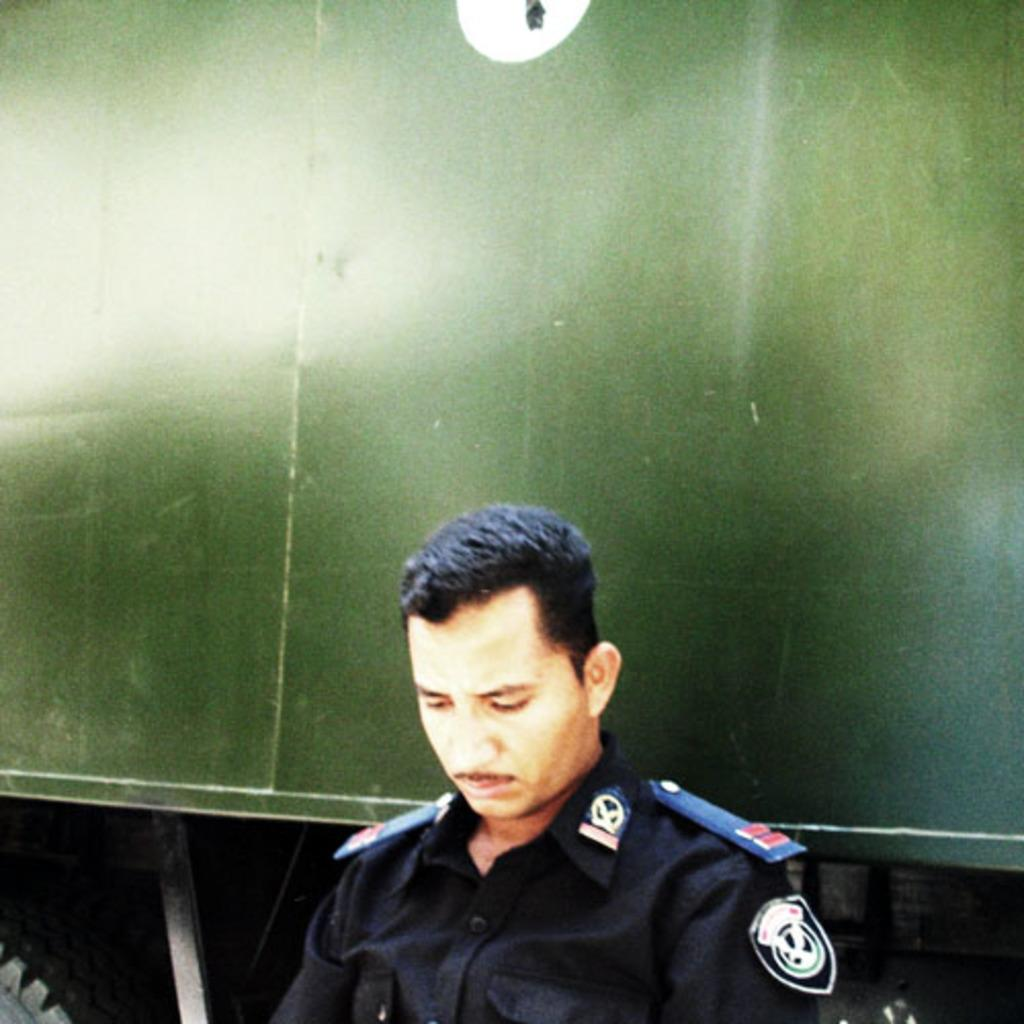Who is present in the image? There is a man in the image. What can be seen in the background of the image? There is a motor vehicle in the background of the image. What shape is the cook making in the image? There is no cook or any indication of shapes being made in the image. 